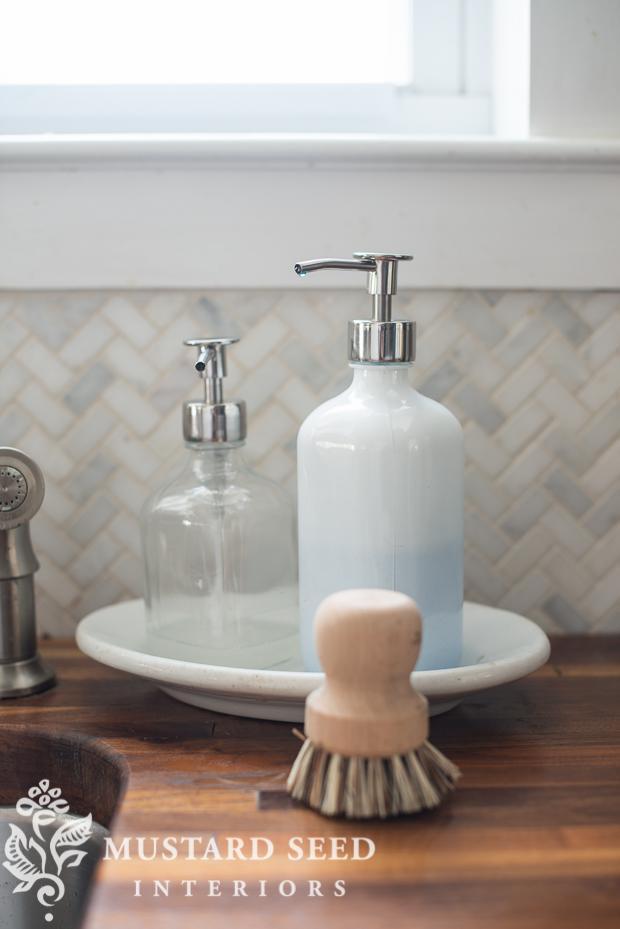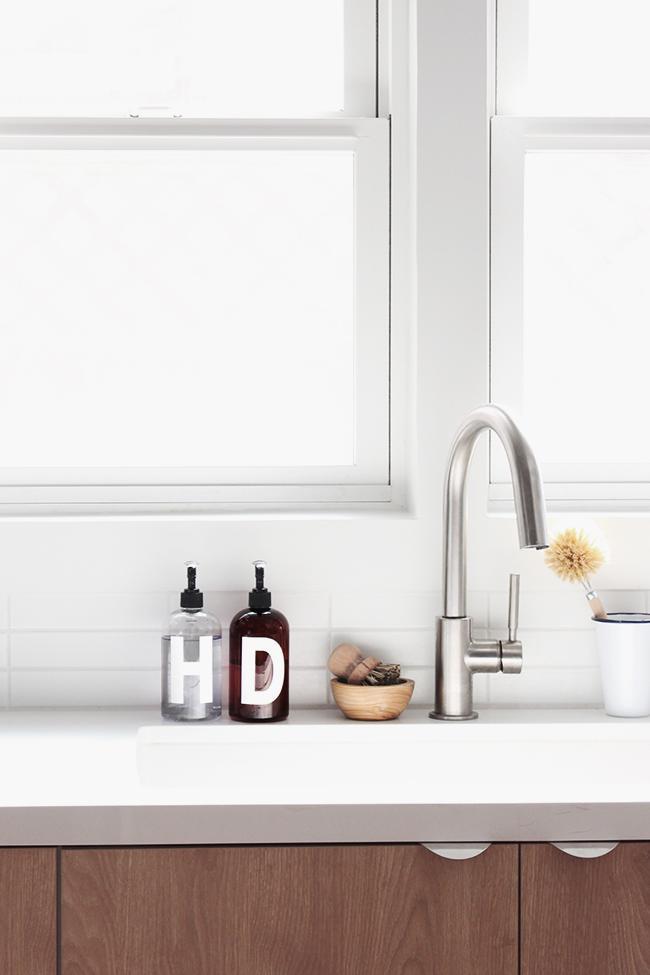The first image is the image on the left, the second image is the image on the right. For the images displayed, is the sentence "There is blue liquid visible inside a clear soap dispenser" factually correct? Answer yes or no. No. The first image is the image on the left, the second image is the image on the right. Examine the images to the left and right. Is the description "An image shows a pump dispenser containing a blue liquid." accurate? Answer yes or no. No. 